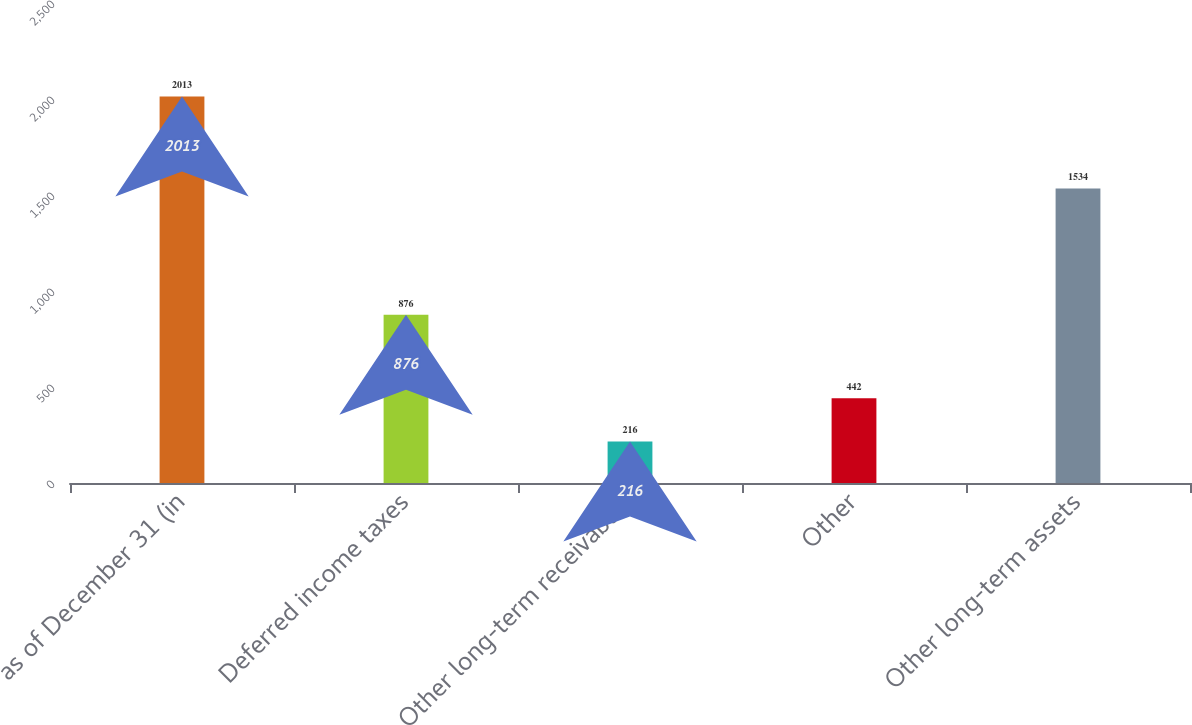Convert chart. <chart><loc_0><loc_0><loc_500><loc_500><bar_chart><fcel>as of December 31 (in<fcel>Deferred income taxes<fcel>Other long-term receivables<fcel>Other<fcel>Other long-term assets<nl><fcel>2013<fcel>876<fcel>216<fcel>442<fcel>1534<nl></chart> 